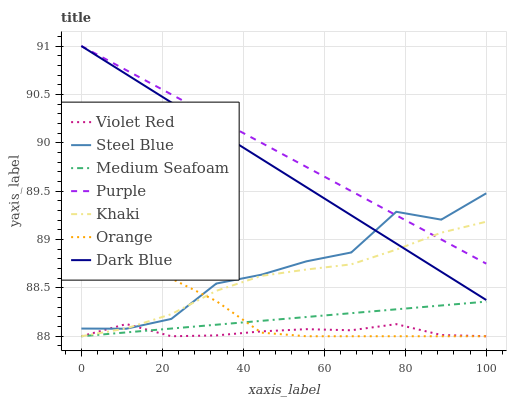Does Violet Red have the minimum area under the curve?
Answer yes or no. Yes. Does Purple have the maximum area under the curve?
Answer yes or no. Yes. Does Khaki have the minimum area under the curve?
Answer yes or no. No. Does Khaki have the maximum area under the curve?
Answer yes or no. No. Is Medium Seafoam the smoothest?
Answer yes or no. Yes. Is Steel Blue the roughest?
Answer yes or no. Yes. Is Khaki the smoothest?
Answer yes or no. No. Is Khaki the roughest?
Answer yes or no. No. Does Violet Red have the lowest value?
Answer yes or no. Yes. Does Purple have the lowest value?
Answer yes or no. No. Does Dark Blue have the highest value?
Answer yes or no. Yes. Does Khaki have the highest value?
Answer yes or no. No. Is Medium Seafoam less than Steel Blue?
Answer yes or no. Yes. Is Dark Blue greater than Violet Red?
Answer yes or no. Yes. Does Violet Red intersect Medium Seafoam?
Answer yes or no. Yes. Is Violet Red less than Medium Seafoam?
Answer yes or no. No. Is Violet Red greater than Medium Seafoam?
Answer yes or no. No. Does Medium Seafoam intersect Steel Blue?
Answer yes or no. No. 